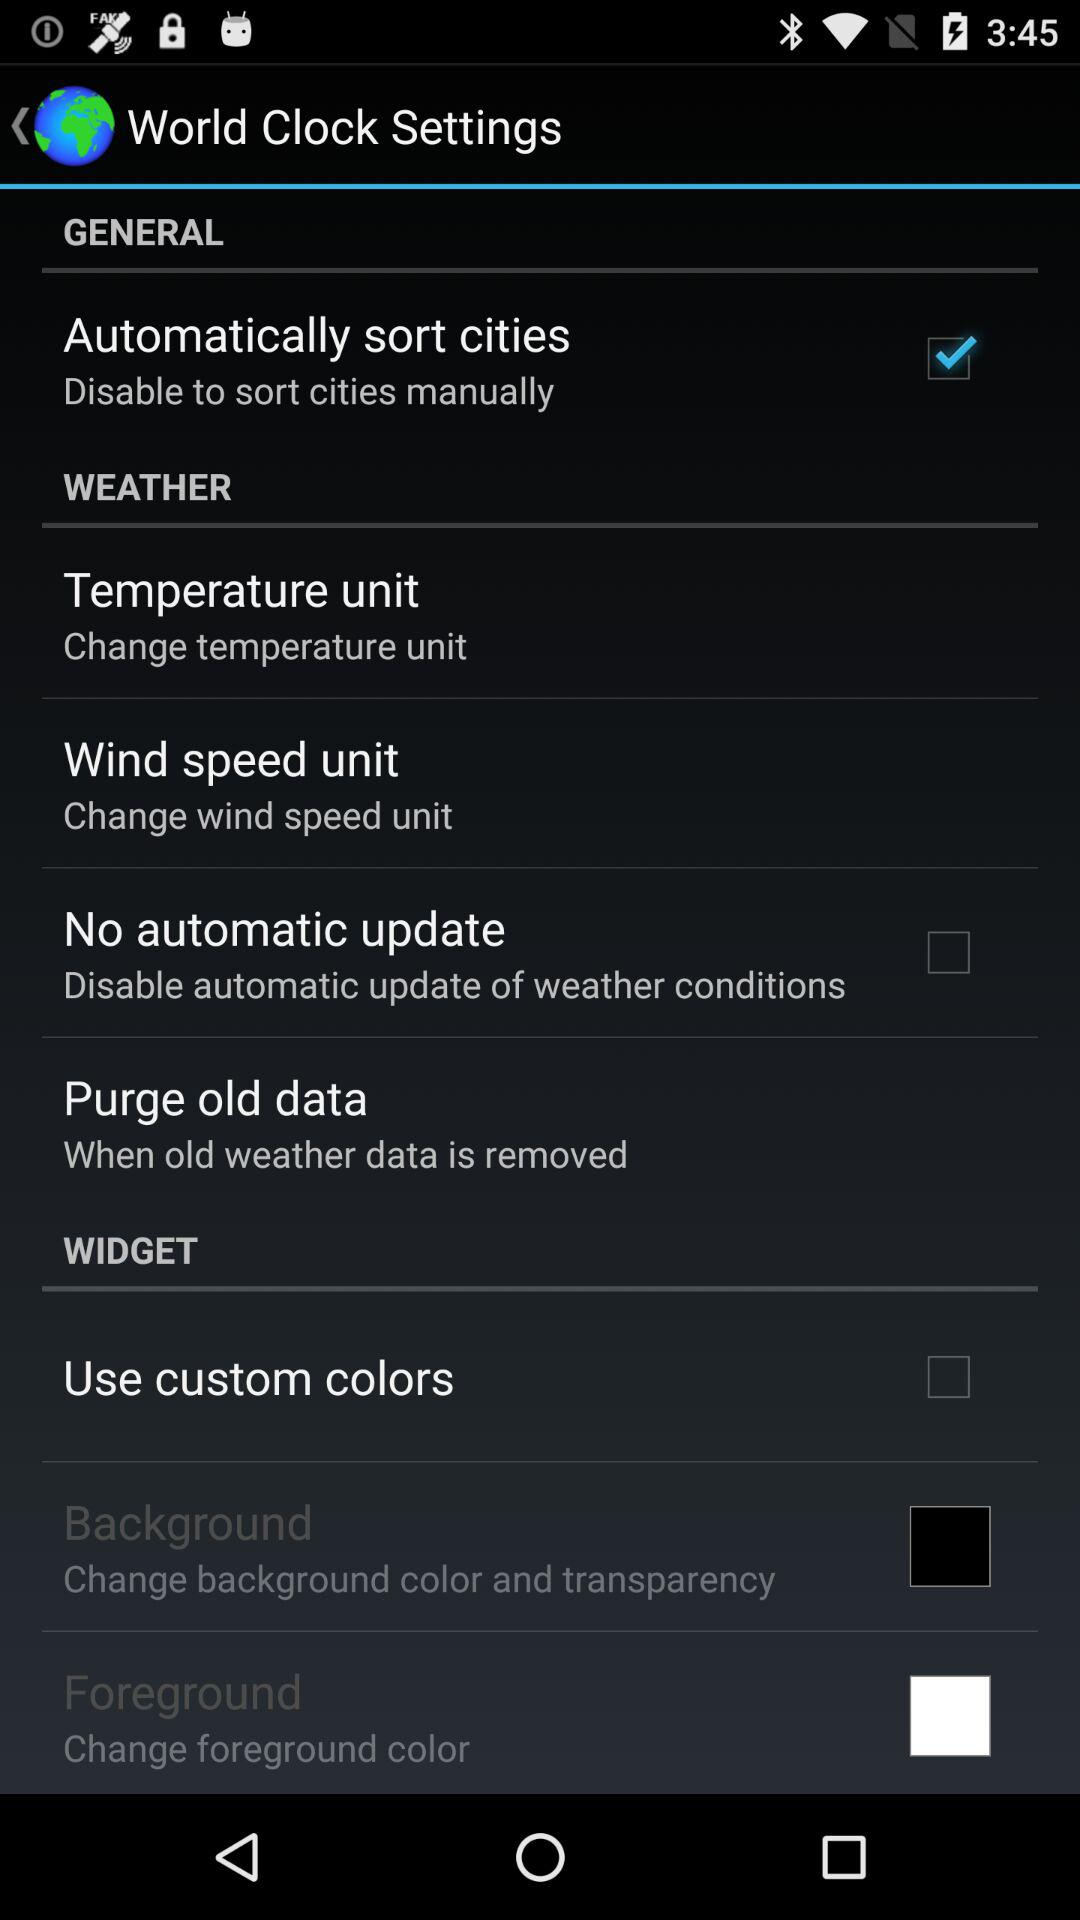What is the status of "Use custom colors"? The status is "off". 